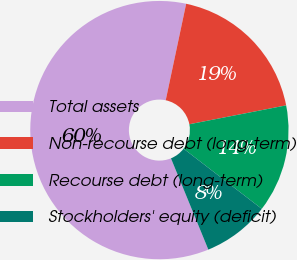Convert chart to OTSL. <chart><loc_0><loc_0><loc_500><loc_500><pie_chart><fcel>Total assets<fcel>Non-recourse debt (long-term)<fcel>Recourse debt (long-term)<fcel>Stockholders' equity (deficit)<nl><fcel>59.51%<fcel>18.61%<fcel>13.5%<fcel>8.38%<nl></chart> 